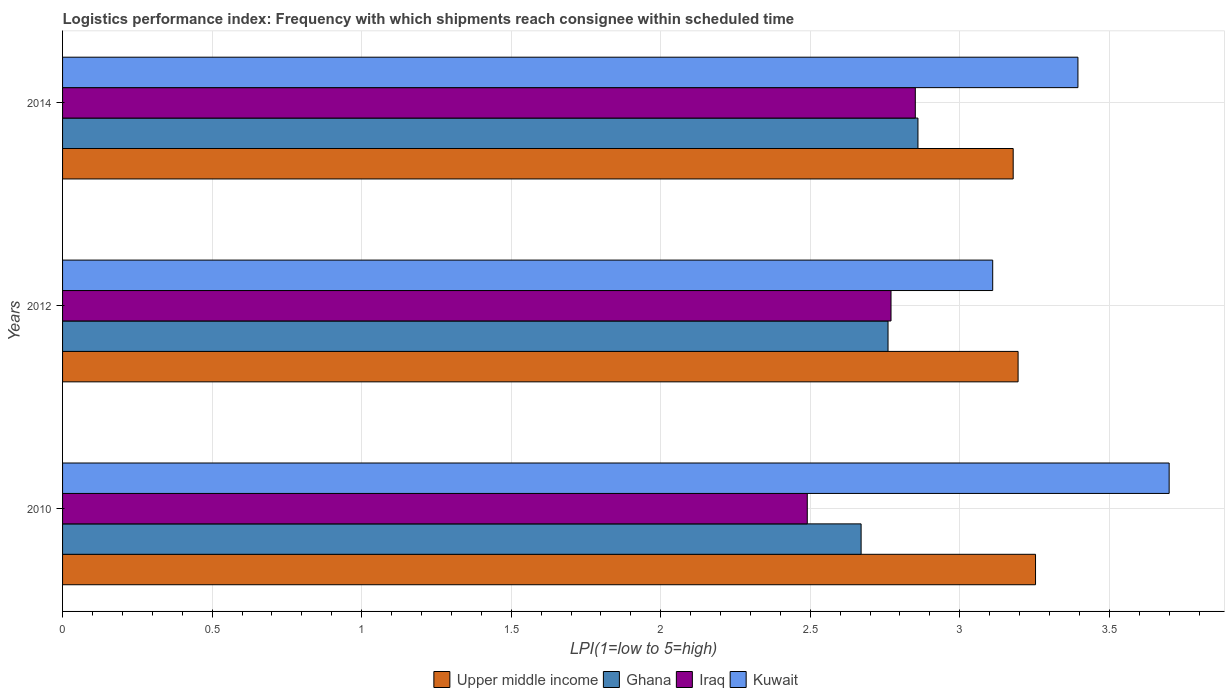How many bars are there on the 2nd tick from the bottom?
Your response must be concise. 4. What is the label of the 2nd group of bars from the top?
Make the answer very short. 2012. What is the logistics performance index in Ghana in 2012?
Provide a succinct answer. 2.76. Across all years, what is the maximum logistics performance index in Ghana?
Your answer should be compact. 2.86. Across all years, what is the minimum logistics performance index in Iraq?
Provide a succinct answer. 2.49. In which year was the logistics performance index in Kuwait maximum?
Offer a terse response. 2010. What is the total logistics performance index in Ghana in the graph?
Provide a short and direct response. 8.29. What is the difference between the logistics performance index in Ghana in 2010 and that in 2014?
Your answer should be compact. -0.19. What is the difference between the logistics performance index in Upper middle income in 2014 and the logistics performance index in Ghana in 2012?
Your response must be concise. 0.42. What is the average logistics performance index in Upper middle income per year?
Your answer should be compact. 3.21. In the year 2014, what is the difference between the logistics performance index in Ghana and logistics performance index in Iraq?
Your response must be concise. 0.01. What is the ratio of the logistics performance index in Iraq in 2010 to that in 2012?
Give a very brief answer. 0.9. Is the logistics performance index in Ghana in 2010 less than that in 2012?
Offer a terse response. Yes. Is the difference between the logistics performance index in Ghana in 2010 and 2012 greater than the difference between the logistics performance index in Iraq in 2010 and 2012?
Offer a very short reply. Yes. What is the difference between the highest and the second highest logistics performance index in Ghana?
Ensure brevity in your answer.  0.1. What is the difference between the highest and the lowest logistics performance index in Upper middle income?
Your answer should be very brief. 0.07. In how many years, is the logistics performance index in Ghana greater than the average logistics performance index in Ghana taken over all years?
Your answer should be compact. 1. Is it the case that in every year, the sum of the logistics performance index in Upper middle income and logistics performance index in Kuwait is greater than the sum of logistics performance index in Iraq and logistics performance index in Ghana?
Provide a short and direct response. Yes. What does the 3rd bar from the top in 2012 represents?
Your response must be concise. Ghana. How many bars are there?
Make the answer very short. 12. Are all the bars in the graph horizontal?
Your response must be concise. Yes. What is the difference between two consecutive major ticks on the X-axis?
Give a very brief answer. 0.5. Where does the legend appear in the graph?
Provide a succinct answer. Bottom center. How many legend labels are there?
Your answer should be very brief. 4. What is the title of the graph?
Make the answer very short. Logistics performance index: Frequency with which shipments reach consignee within scheduled time. Does "Pacific island small states" appear as one of the legend labels in the graph?
Offer a terse response. No. What is the label or title of the X-axis?
Ensure brevity in your answer.  LPI(1=low to 5=high). What is the label or title of the Y-axis?
Offer a terse response. Years. What is the LPI(1=low to 5=high) in Upper middle income in 2010?
Keep it short and to the point. 3.25. What is the LPI(1=low to 5=high) in Ghana in 2010?
Your answer should be compact. 2.67. What is the LPI(1=low to 5=high) of Iraq in 2010?
Provide a short and direct response. 2.49. What is the LPI(1=low to 5=high) in Upper middle income in 2012?
Offer a very short reply. 3.19. What is the LPI(1=low to 5=high) in Ghana in 2012?
Provide a succinct answer. 2.76. What is the LPI(1=low to 5=high) in Iraq in 2012?
Make the answer very short. 2.77. What is the LPI(1=low to 5=high) of Kuwait in 2012?
Give a very brief answer. 3.11. What is the LPI(1=low to 5=high) in Upper middle income in 2014?
Make the answer very short. 3.18. What is the LPI(1=low to 5=high) of Ghana in 2014?
Give a very brief answer. 2.86. What is the LPI(1=low to 5=high) in Iraq in 2014?
Offer a very short reply. 2.85. What is the LPI(1=low to 5=high) of Kuwait in 2014?
Provide a short and direct response. 3.39. Across all years, what is the maximum LPI(1=low to 5=high) of Upper middle income?
Keep it short and to the point. 3.25. Across all years, what is the maximum LPI(1=low to 5=high) of Ghana?
Your response must be concise. 2.86. Across all years, what is the maximum LPI(1=low to 5=high) of Iraq?
Make the answer very short. 2.85. Across all years, what is the minimum LPI(1=low to 5=high) in Upper middle income?
Ensure brevity in your answer.  3.18. Across all years, what is the minimum LPI(1=low to 5=high) in Ghana?
Keep it short and to the point. 2.67. Across all years, what is the minimum LPI(1=low to 5=high) of Iraq?
Your response must be concise. 2.49. Across all years, what is the minimum LPI(1=low to 5=high) in Kuwait?
Offer a very short reply. 3.11. What is the total LPI(1=low to 5=high) in Upper middle income in the graph?
Keep it short and to the point. 9.63. What is the total LPI(1=low to 5=high) of Ghana in the graph?
Offer a very short reply. 8.29. What is the total LPI(1=low to 5=high) in Iraq in the graph?
Offer a very short reply. 8.11. What is the total LPI(1=low to 5=high) of Kuwait in the graph?
Keep it short and to the point. 10.21. What is the difference between the LPI(1=low to 5=high) in Upper middle income in 2010 and that in 2012?
Offer a very short reply. 0.06. What is the difference between the LPI(1=low to 5=high) in Ghana in 2010 and that in 2012?
Provide a succinct answer. -0.09. What is the difference between the LPI(1=low to 5=high) in Iraq in 2010 and that in 2012?
Your answer should be very brief. -0.28. What is the difference between the LPI(1=low to 5=high) of Kuwait in 2010 and that in 2012?
Your answer should be compact. 0.59. What is the difference between the LPI(1=low to 5=high) in Upper middle income in 2010 and that in 2014?
Keep it short and to the point. 0.07. What is the difference between the LPI(1=low to 5=high) of Ghana in 2010 and that in 2014?
Ensure brevity in your answer.  -0.19. What is the difference between the LPI(1=low to 5=high) of Iraq in 2010 and that in 2014?
Make the answer very short. -0.36. What is the difference between the LPI(1=low to 5=high) of Kuwait in 2010 and that in 2014?
Your answer should be compact. 0.3. What is the difference between the LPI(1=low to 5=high) in Upper middle income in 2012 and that in 2014?
Your answer should be very brief. 0.02. What is the difference between the LPI(1=low to 5=high) of Ghana in 2012 and that in 2014?
Ensure brevity in your answer.  -0.1. What is the difference between the LPI(1=low to 5=high) of Iraq in 2012 and that in 2014?
Your answer should be very brief. -0.08. What is the difference between the LPI(1=low to 5=high) in Kuwait in 2012 and that in 2014?
Offer a terse response. -0.28. What is the difference between the LPI(1=low to 5=high) of Upper middle income in 2010 and the LPI(1=low to 5=high) of Ghana in 2012?
Offer a very short reply. 0.49. What is the difference between the LPI(1=low to 5=high) in Upper middle income in 2010 and the LPI(1=low to 5=high) in Iraq in 2012?
Ensure brevity in your answer.  0.48. What is the difference between the LPI(1=low to 5=high) of Upper middle income in 2010 and the LPI(1=low to 5=high) of Kuwait in 2012?
Your answer should be very brief. 0.14. What is the difference between the LPI(1=low to 5=high) in Ghana in 2010 and the LPI(1=low to 5=high) in Iraq in 2012?
Provide a succinct answer. -0.1. What is the difference between the LPI(1=low to 5=high) in Ghana in 2010 and the LPI(1=low to 5=high) in Kuwait in 2012?
Offer a very short reply. -0.44. What is the difference between the LPI(1=low to 5=high) in Iraq in 2010 and the LPI(1=low to 5=high) in Kuwait in 2012?
Ensure brevity in your answer.  -0.62. What is the difference between the LPI(1=low to 5=high) in Upper middle income in 2010 and the LPI(1=low to 5=high) in Ghana in 2014?
Offer a very short reply. 0.39. What is the difference between the LPI(1=low to 5=high) of Upper middle income in 2010 and the LPI(1=low to 5=high) of Iraq in 2014?
Ensure brevity in your answer.  0.4. What is the difference between the LPI(1=low to 5=high) of Upper middle income in 2010 and the LPI(1=low to 5=high) of Kuwait in 2014?
Ensure brevity in your answer.  -0.14. What is the difference between the LPI(1=low to 5=high) in Ghana in 2010 and the LPI(1=low to 5=high) in Iraq in 2014?
Your answer should be compact. -0.18. What is the difference between the LPI(1=low to 5=high) of Ghana in 2010 and the LPI(1=low to 5=high) of Kuwait in 2014?
Offer a terse response. -0.72. What is the difference between the LPI(1=low to 5=high) of Iraq in 2010 and the LPI(1=low to 5=high) of Kuwait in 2014?
Provide a short and direct response. -0.91. What is the difference between the LPI(1=low to 5=high) in Upper middle income in 2012 and the LPI(1=low to 5=high) in Ghana in 2014?
Offer a very short reply. 0.33. What is the difference between the LPI(1=low to 5=high) of Upper middle income in 2012 and the LPI(1=low to 5=high) of Iraq in 2014?
Provide a short and direct response. 0.34. What is the difference between the LPI(1=low to 5=high) in Upper middle income in 2012 and the LPI(1=low to 5=high) in Kuwait in 2014?
Give a very brief answer. -0.2. What is the difference between the LPI(1=low to 5=high) of Ghana in 2012 and the LPI(1=low to 5=high) of Iraq in 2014?
Offer a very short reply. -0.09. What is the difference between the LPI(1=low to 5=high) in Ghana in 2012 and the LPI(1=low to 5=high) in Kuwait in 2014?
Give a very brief answer. -0.64. What is the difference between the LPI(1=low to 5=high) of Iraq in 2012 and the LPI(1=low to 5=high) of Kuwait in 2014?
Your response must be concise. -0.62. What is the average LPI(1=low to 5=high) in Upper middle income per year?
Ensure brevity in your answer.  3.21. What is the average LPI(1=low to 5=high) in Ghana per year?
Keep it short and to the point. 2.76. What is the average LPI(1=low to 5=high) in Iraq per year?
Make the answer very short. 2.7. What is the average LPI(1=low to 5=high) of Kuwait per year?
Offer a very short reply. 3.4. In the year 2010, what is the difference between the LPI(1=low to 5=high) in Upper middle income and LPI(1=low to 5=high) in Ghana?
Provide a succinct answer. 0.58. In the year 2010, what is the difference between the LPI(1=low to 5=high) of Upper middle income and LPI(1=low to 5=high) of Iraq?
Keep it short and to the point. 0.76. In the year 2010, what is the difference between the LPI(1=low to 5=high) of Upper middle income and LPI(1=low to 5=high) of Kuwait?
Keep it short and to the point. -0.45. In the year 2010, what is the difference between the LPI(1=low to 5=high) in Ghana and LPI(1=low to 5=high) in Iraq?
Your response must be concise. 0.18. In the year 2010, what is the difference between the LPI(1=low to 5=high) in Ghana and LPI(1=low to 5=high) in Kuwait?
Keep it short and to the point. -1.03. In the year 2010, what is the difference between the LPI(1=low to 5=high) of Iraq and LPI(1=low to 5=high) of Kuwait?
Offer a very short reply. -1.21. In the year 2012, what is the difference between the LPI(1=low to 5=high) of Upper middle income and LPI(1=low to 5=high) of Ghana?
Offer a terse response. 0.43. In the year 2012, what is the difference between the LPI(1=low to 5=high) of Upper middle income and LPI(1=low to 5=high) of Iraq?
Make the answer very short. 0.42. In the year 2012, what is the difference between the LPI(1=low to 5=high) of Upper middle income and LPI(1=low to 5=high) of Kuwait?
Offer a very short reply. 0.08. In the year 2012, what is the difference between the LPI(1=low to 5=high) in Ghana and LPI(1=low to 5=high) in Iraq?
Offer a very short reply. -0.01. In the year 2012, what is the difference between the LPI(1=low to 5=high) of Ghana and LPI(1=low to 5=high) of Kuwait?
Ensure brevity in your answer.  -0.35. In the year 2012, what is the difference between the LPI(1=low to 5=high) of Iraq and LPI(1=low to 5=high) of Kuwait?
Your answer should be very brief. -0.34. In the year 2014, what is the difference between the LPI(1=low to 5=high) in Upper middle income and LPI(1=low to 5=high) in Ghana?
Give a very brief answer. 0.32. In the year 2014, what is the difference between the LPI(1=low to 5=high) of Upper middle income and LPI(1=low to 5=high) of Iraq?
Ensure brevity in your answer.  0.33. In the year 2014, what is the difference between the LPI(1=low to 5=high) of Upper middle income and LPI(1=low to 5=high) of Kuwait?
Your answer should be very brief. -0.22. In the year 2014, what is the difference between the LPI(1=low to 5=high) of Ghana and LPI(1=low to 5=high) of Iraq?
Offer a very short reply. 0.01. In the year 2014, what is the difference between the LPI(1=low to 5=high) in Ghana and LPI(1=low to 5=high) in Kuwait?
Provide a short and direct response. -0.53. In the year 2014, what is the difference between the LPI(1=low to 5=high) of Iraq and LPI(1=low to 5=high) of Kuwait?
Ensure brevity in your answer.  -0.54. What is the ratio of the LPI(1=low to 5=high) of Upper middle income in 2010 to that in 2012?
Ensure brevity in your answer.  1.02. What is the ratio of the LPI(1=low to 5=high) of Ghana in 2010 to that in 2012?
Keep it short and to the point. 0.97. What is the ratio of the LPI(1=low to 5=high) of Iraq in 2010 to that in 2012?
Make the answer very short. 0.9. What is the ratio of the LPI(1=low to 5=high) in Kuwait in 2010 to that in 2012?
Keep it short and to the point. 1.19. What is the ratio of the LPI(1=low to 5=high) of Upper middle income in 2010 to that in 2014?
Ensure brevity in your answer.  1.02. What is the ratio of the LPI(1=low to 5=high) of Ghana in 2010 to that in 2014?
Your answer should be compact. 0.93. What is the ratio of the LPI(1=low to 5=high) of Iraq in 2010 to that in 2014?
Provide a succinct answer. 0.87. What is the ratio of the LPI(1=low to 5=high) of Kuwait in 2010 to that in 2014?
Provide a short and direct response. 1.09. What is the ratio of the LPI(1=low to 5=high) of Iraq in 2012 to that in 2014?
Make the answer very short. 0.97. What is the ratio of the LPI(1=low to 5=high) in Kuwait in 2012 to that in 2014?
Keep it short and to the point. 0.92. What is the difference between the highest and the second highest LPI(1=low to 5=high) of Upper middle income?
Keep it short and to the point. 0.06. What is the difference between the highest and the second highest LPI(1=low to 5=high) of Iraq?
Your answer should be compact. 0.08. What is the difference between the highest and the second highest LPI(1=low to 5=high) of Kuwait?
Provide a short and direct response. 0.3. What is the difference between the highest and the lowest LPI(1=low to 5=high) in Upper middle income?
Your response must be concise. 0.07. What is the difference between the highest and the lowest LPI(1=low to 5=high) of Ghana?
Ensure brevity in your answer.  0.19. What is the difference between the highest and the lowest LPI(1=low to 5=high) of Iraq?
Your answer should be compact. 0.36. What is the difference between the highest and the lowest LPI(1=low to 5=high) of Kuwait?
Offer a terse response. 0.59. 